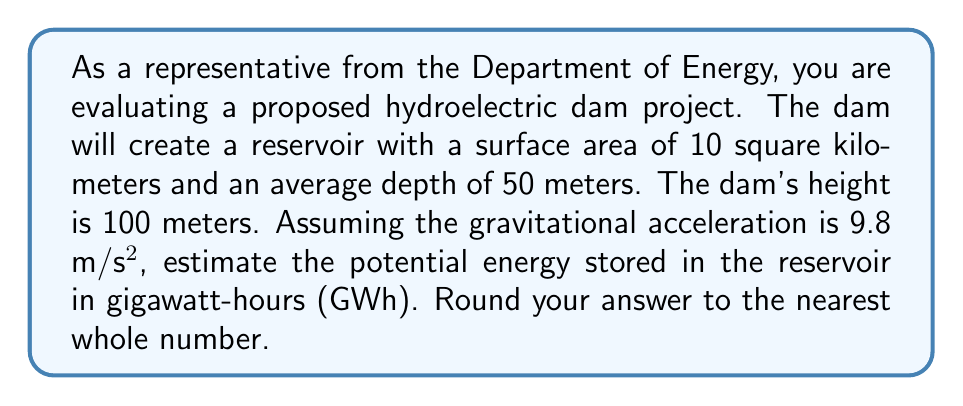Can you answer this question? To solve this problem, we'll follow these steps:

1. Calculate the volume of water in the reservoir:
   $$V = A \times d$$
   where $A$ is the surface area and $d$ is the average depth.
   $$V = 10 \text{ km}^2 \times 50 \text{ m} = 5 \times 10^8 \text{ m}^3$$

2. Calculate the mass of water:
   $$m = \rho \times V$$
   where $\rho$ is the density of water (1000 kg/m³).
   $$m = 1000 \text{ kg/m}^3 \times 5 \times 10^8 \text{ m}^3 = 5 \times 10^{11} \text{ kg}$$

3. Calculate the potential energy:
   $$E_p = mgh$$
   where $m$ is the mass, $g$ is gravitational acceleration, and $h$ is the height.
   $$E_p = 5 \times 10^{11} \text{ kg} \times 9.8 \text{ m/s}^2 \times 100 \text{ m} = 4.9 \times 10^{14} \text{ J}$$

4. Convert joules to gigawatt-hours:
   $$1 \text{ GWh} = 3.6 \times 10^{12} \text{ J}$$
   $$\text{Energy in GWh} = \frac{4.9 \times 10^{14} \text{ J}}{3.6 \times 10^{12} \text{ J/GWh}} \approx 136.11 \text{ GWh}$$

5. Round to the nearest whole number:
   136 GWh
Answer: 136 GWh 